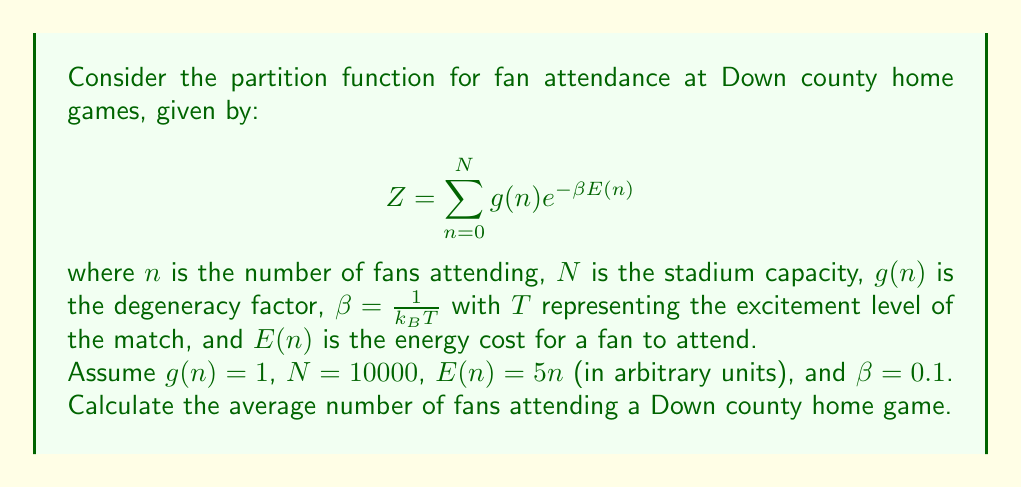Show me your answer to this math problem. To solve this problem, we'll follow these steps:

1) First, we need to calculate the partition function $Z$:

   $$Z = \sum_{n=0}^{10000} e^{-0.1 \cdot 5n} = \sum_{n=0}^{10000} e^{-0.5n}$$

   This is a geometric series with $10001$ terms, where the first term $a = 1$ and the common ratio $r = e^{-0.5}$.

2) We can use the formula for the sum of a geometric series:

   $$S_n = \frac{a(1-r^{n+1})}{1-r}$$

   where $S_n$ is the sum of the first $n+1$ terms.

3) Plugging in our values:

   $$Z = \frac{1-e^{-0.5(10001)}}{1-e^{-0.5}} \approx 1.6487$$

4) Now, to find the average number of fans, we need to calculate $\langle n \rangle$:

   $$\langle n \rangle = -\frac{\partial \ln Z}{\partial \beta} = \frac{1}{Z} \frac{\partial Z}{\partial \beta}$$

5) We can calculate this derivative:

   $$\frac{\partial Z}{\partial \beta} = \sum_{n=0}^{10000} -5n e^{-0.5n} \approx -8.2435$$

6) Now we can calculate $\langle n \rangle$:

   $$\langle n \rangle = \frac{1}{1.6487} \cdot 8.2435 \approx 5$$

Therefore, the average number of fans attending a Down county home game under these conditions is approximately 5.
Answer: 5 fans 